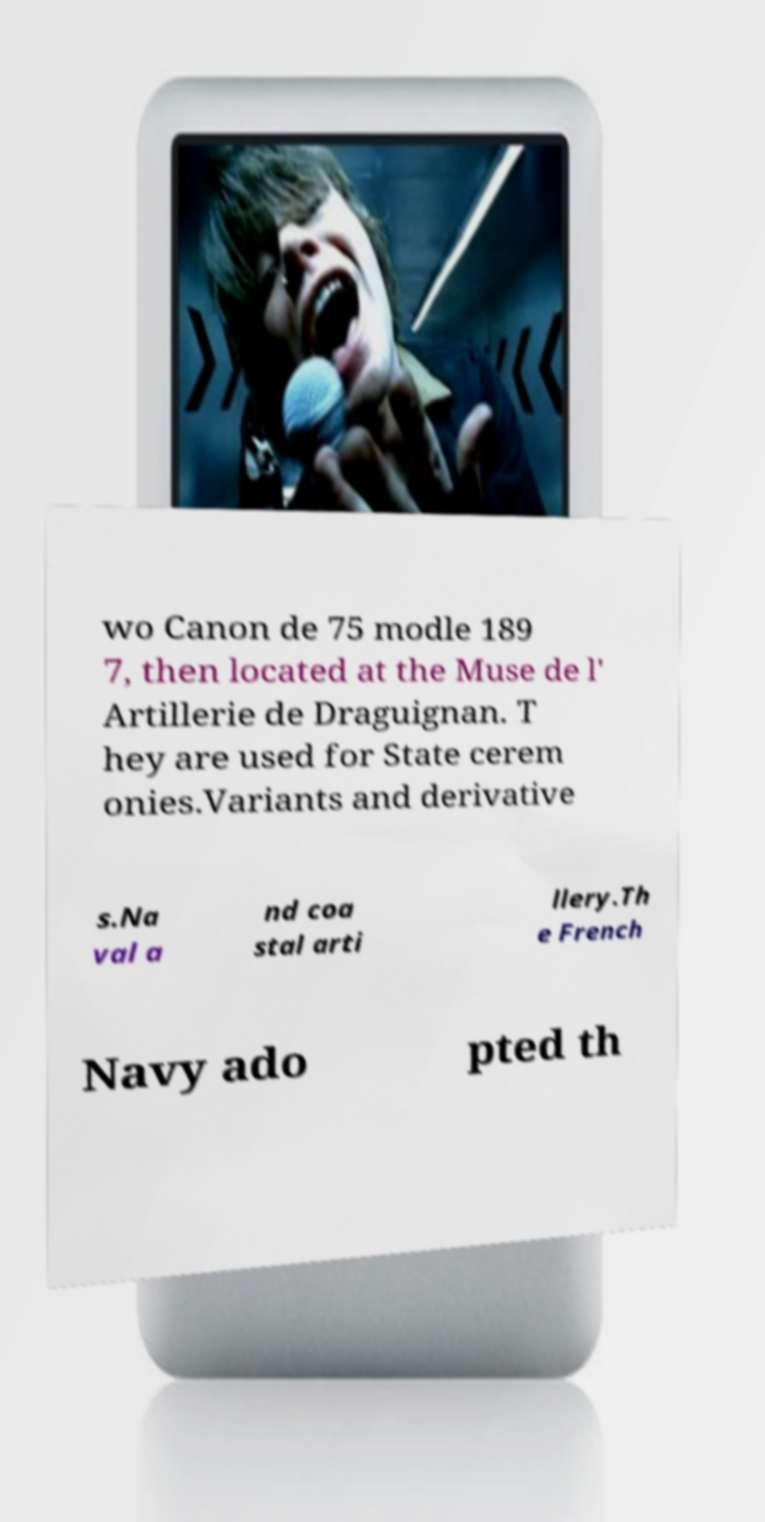What messages or text are displayed in this image? I need them in a readable, typed format. wo Canon de 75 modle 189 7, then located at the Muse de l' Artillerie de Draguignan. T hey are used for State cerem onies.Variants and derivative s.Na val a nd coa stal arti llery.Th e French Navy ado pted th 